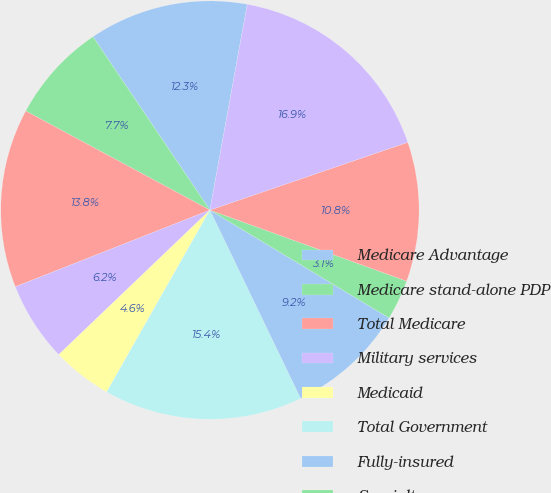Convert chart to OTSL. <chart><loc_0><loc_0><loc_500><loc_500><pie_chart><fcel>Medicare Advantage<fcel>Medicare stand-alone PDP<fcel>Total Medicare<fcel>Military services<fcel>Medicaid<fcel>Total Government<fcel>Fully-insured<fcel>Specialty<fcel>Total Commercial<fcel>Total<nl><fcel>12.3%<fcel>7.7%<fcel>13.83%<fcel>6.17%<fcel>4.64%<fcel>15.36%<fcel>9.23%<fcel>3.11%<fcel>10.77%<fcel>16.89%<nl></chart> 